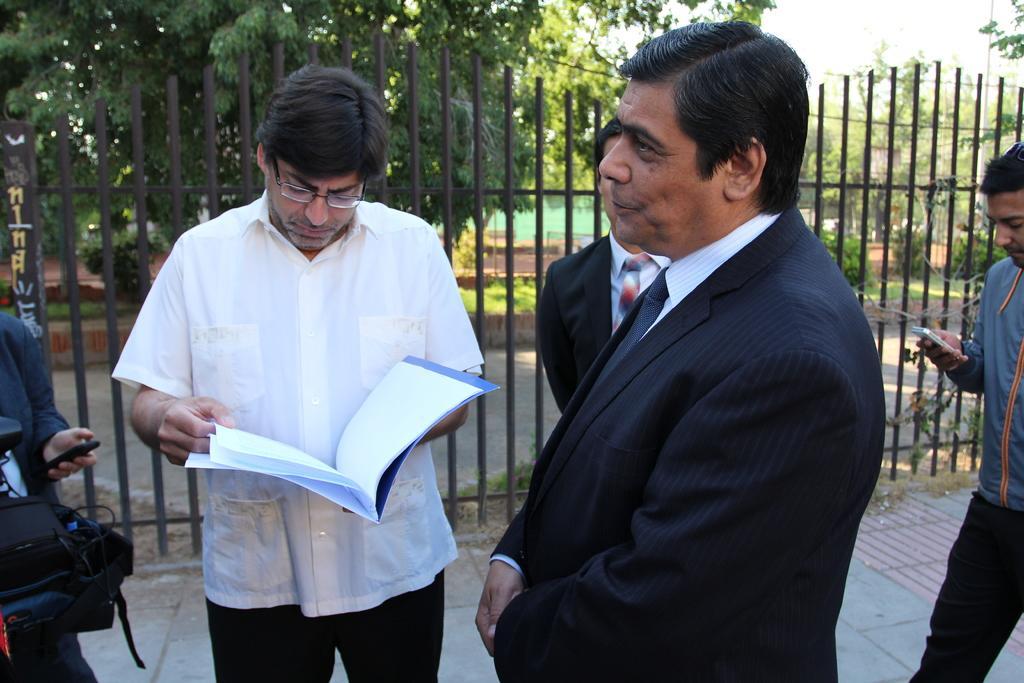How would you summarize this image in a sentence or two? I can see this image few men are standing on the ground. The person on the left side is holding a book in his hand, the person on the right side is wearing black suit. In the background I can see a fence, couple of trees on the ground. 